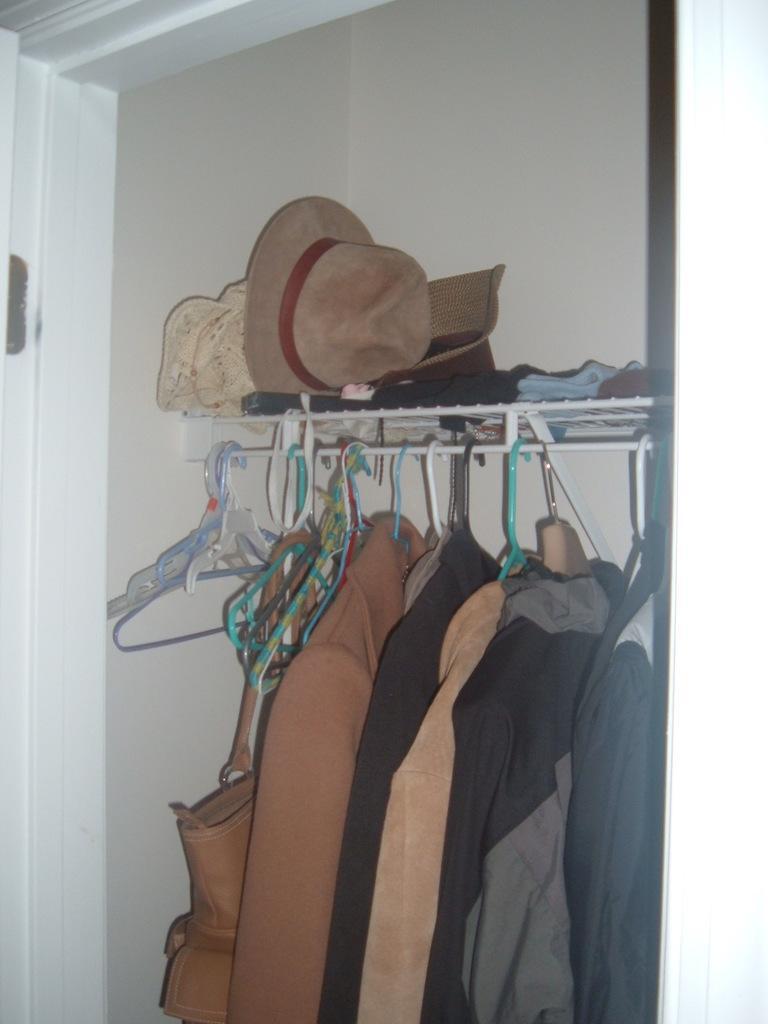Can you describe this image briefly? Here we can see clothes, hangers, bag, and hats. There is a white background. 